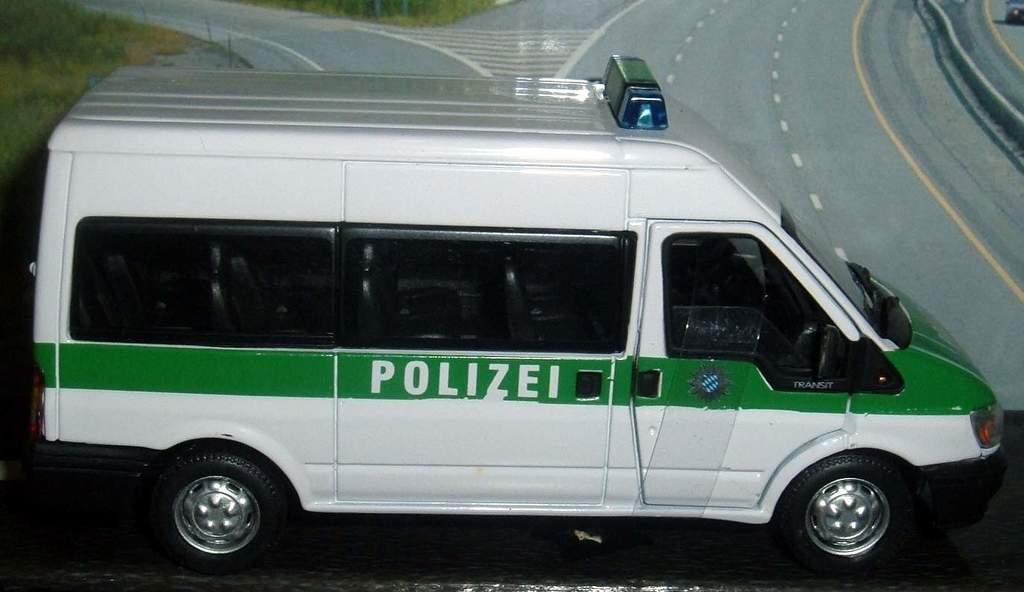Does this translate to "police" in english?
Offer a terse response. Unanswerable. 